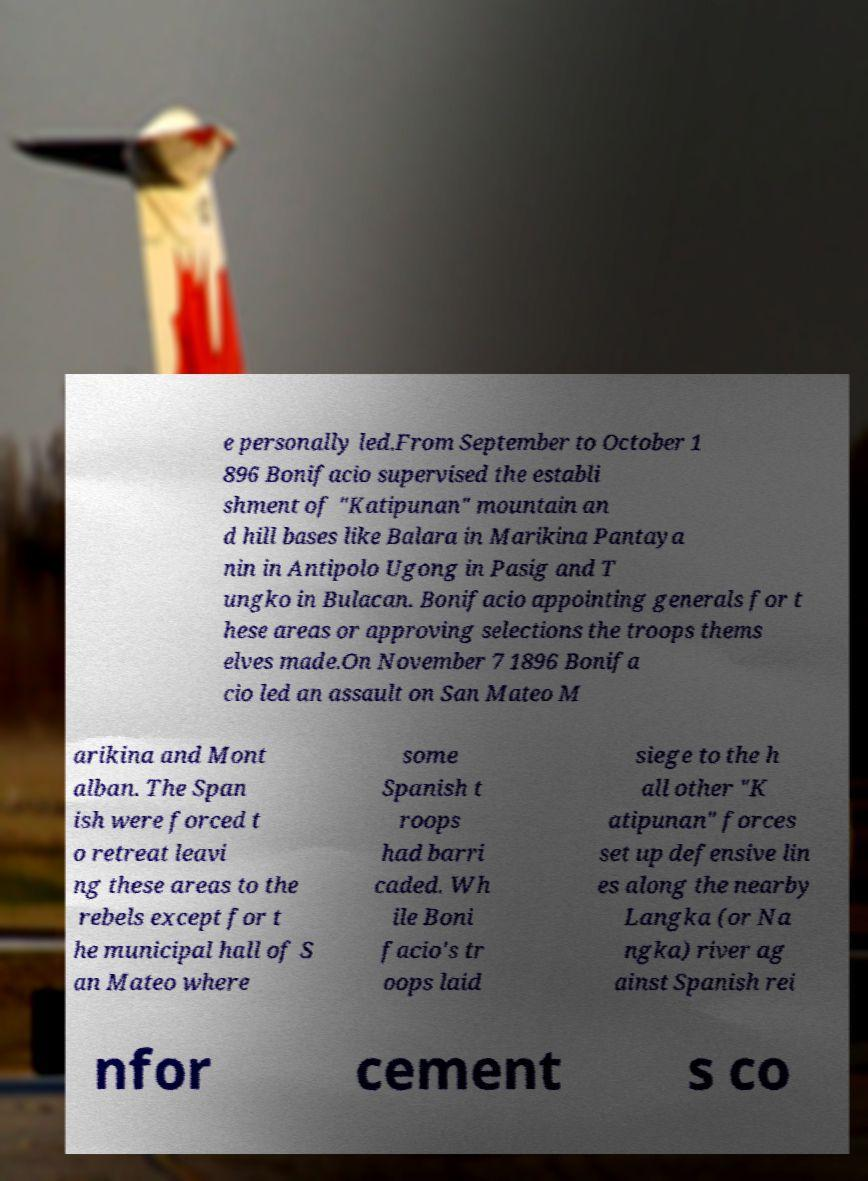What messages or text are displayed in this image? I need them in a readable, typed format. e personally led.From September to October 1 896 Bonifacio supervised the establi shment of "Katipunan" mountain an d hill bases like Balara in Marikina Pantaya nin in Antipolo Ugong in Pasig and T ungko in Bulacan. Bonifacio appointing generals for t hese areas or approving selections the troops thems elves made.On November 7 1896 Bonifa cio led an assault on San Mateo M arikina and Mont alban. The Span ish were forced t o retreat leavi ng these areas to the rebels except for t he municipal hall of S an Mateo where some Spanish t roops had barri caded. Wh ile Boni facio's tr oops laid siege to the h all other "K atipunan" forces set up defensive lin es along the nearby Langka (or Na ngka) river ag ainst Spanish rei nfor cement s co 